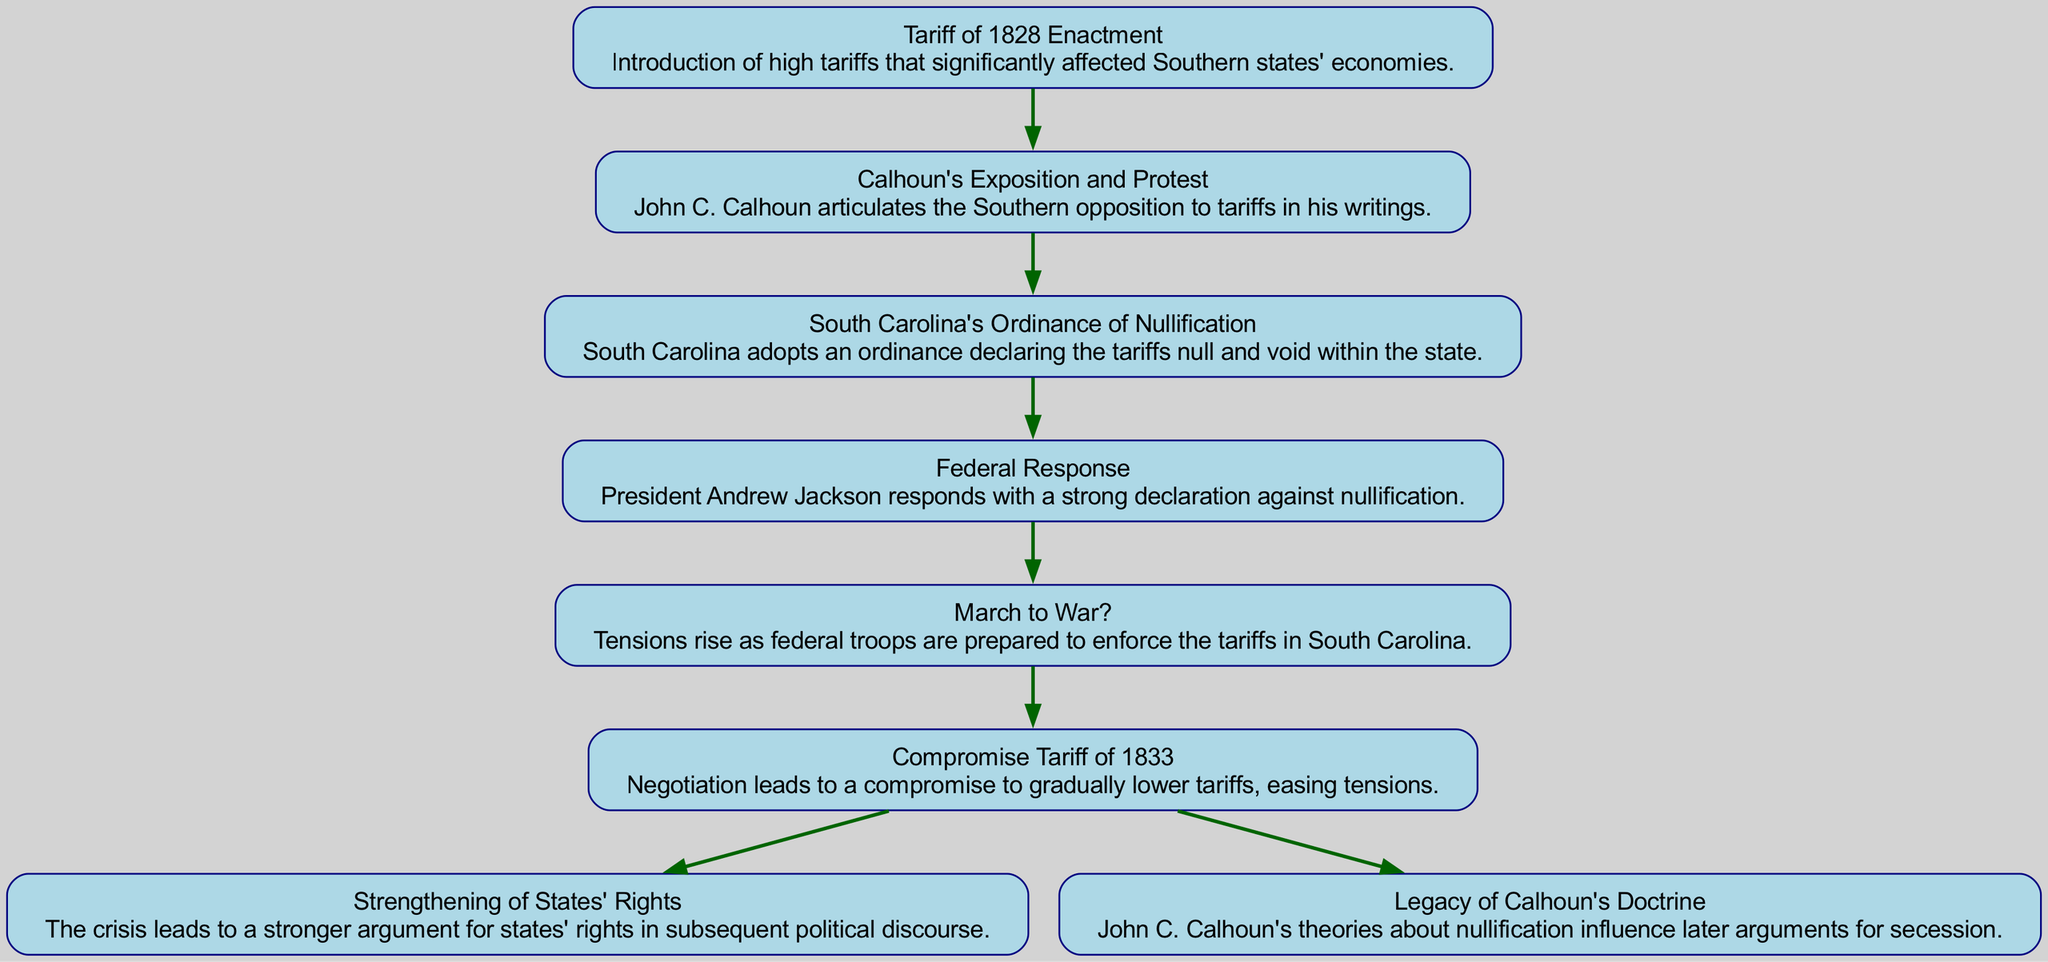What is the first step in the flow chart? The first step is labeled "Tariff of 1828 Enactment," which signifies the initial event that triggers the subsequent actions in the diagram.
Answer: Tariff of 1828 Enactment How many total steps are depicted in the flow chart? By counting the steps, from "Step 1" to "Step 6," we find there are 6 steps that lead to the consequences.
Answer: 6 What does South Carolina adopt in Step 3? In Step 3, it specifies that South Carolina adopts an ordinance which declares the tariffs null and void, highlighting a significant act of defiance against federal policies.
Answer: Ordinance of Nullification What is the consequence of the crisis that emphasizes states' rights? The consequence labeled "Strengthening of States' Rights" indicates that as a result of the crisis, there is a stronger argument presented for states' rights in the future political landscape.
Answer: Strengthening of States' Rights What follows the "Federal Response" in the sequence? The next step after "Federal Response" is "March to War?" which illustrates the increasing tension and the possibility of violent confrontation following the federal government's strong stance against nullification.
Answer: March to War? What is the outcome concerning Calhoun's influence as shown in the consequences? The outcome labeled "Legacy of Calhoun's Doctrine" suggests that his theoretical framework regarding nullification has a lasting impact, as it continues to affect future discussions surrounding secession.
Answer: Legacy of Calhoun's Doctrine What leads to the "Compromise Tariff of 1833"? The flow from "March to War?" highlights that the escalating tensions prompt negotiations, which culminate in the "Compromise Tariff of 1833," aiming to soothe the conflict between the states and the federal government.
Answer: Negotiation What color is used for the nodes in the diagram? The diagram uses a light blue fill color for the nodes, providing a visually distinct representation of each step and consequence within the flow chart.
Answer: Light blue How does the time sequence flow between the steps? The sequence shows a directional flow from one step to the next, indicating a chronological progression of events from the initial tariff enactment to the eventual consequences, where the edges connect these steps in a clear, logical order.
Answer: Chronological progression 